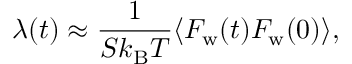Convert formula to latex. <formula><loc_0><loc_0><loc_500><loc_500>\lambda ( t ) \approx \frac { 1 } { S k _ { B } T } \langle F _ { w } ( t ) F _ { w } ( 0 ) \rangle ,</formula> 